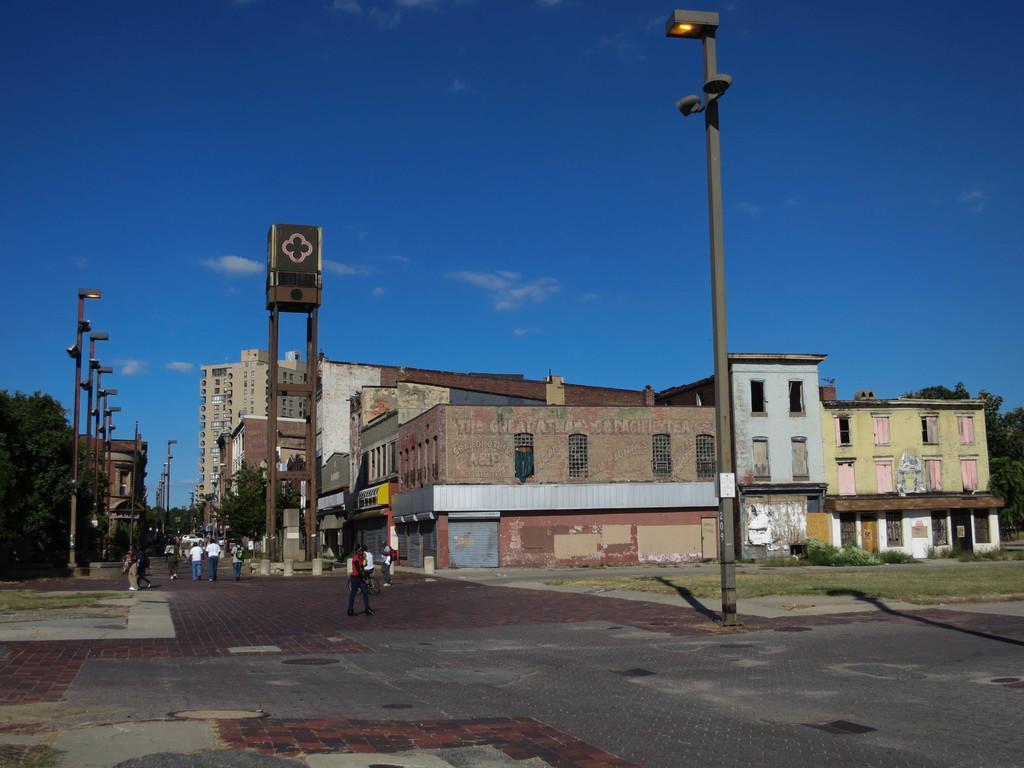How would you summarize this image in a sentence or two? At the bottom of the image we can see people walking. On the left there is a tree. In the background there are buildings. In the center we can see a pole. At the top there is sky. 